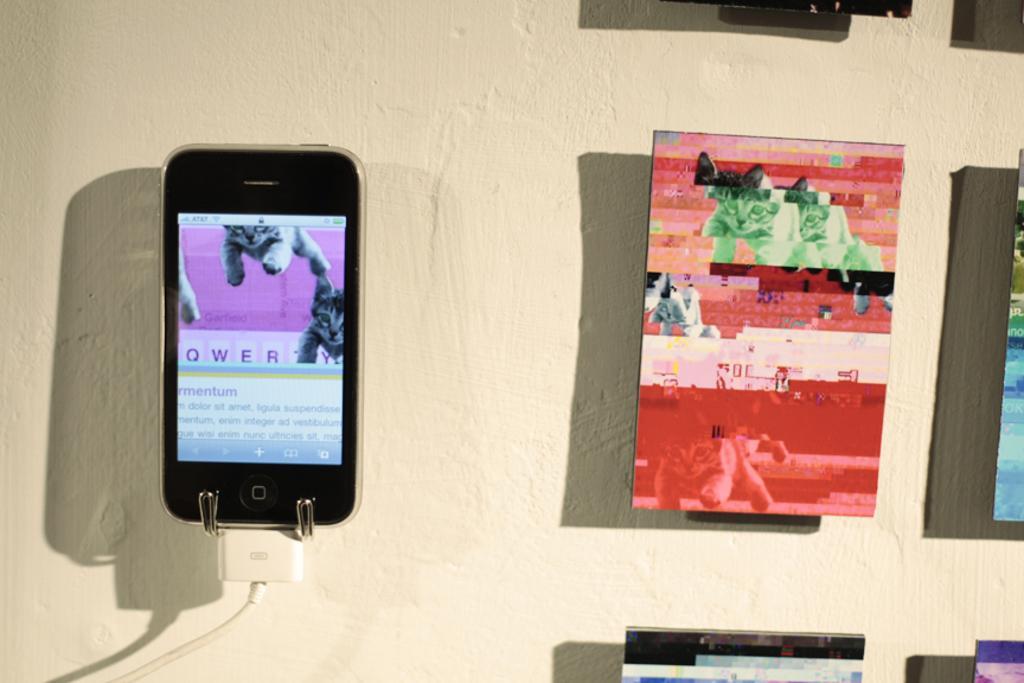Can you describe this image briefly? In this image there is a mobile connected to a cable and hanging on the wall, beside the mobile there are a few frames are hanging on the wall. 